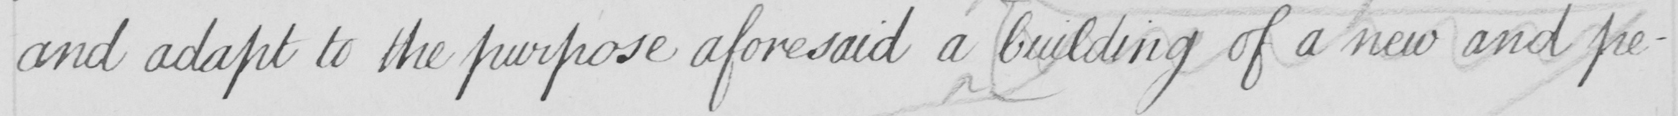What is written in this line of handwriting? and adapt to the purpose aforesaid a building of a new and pe- 